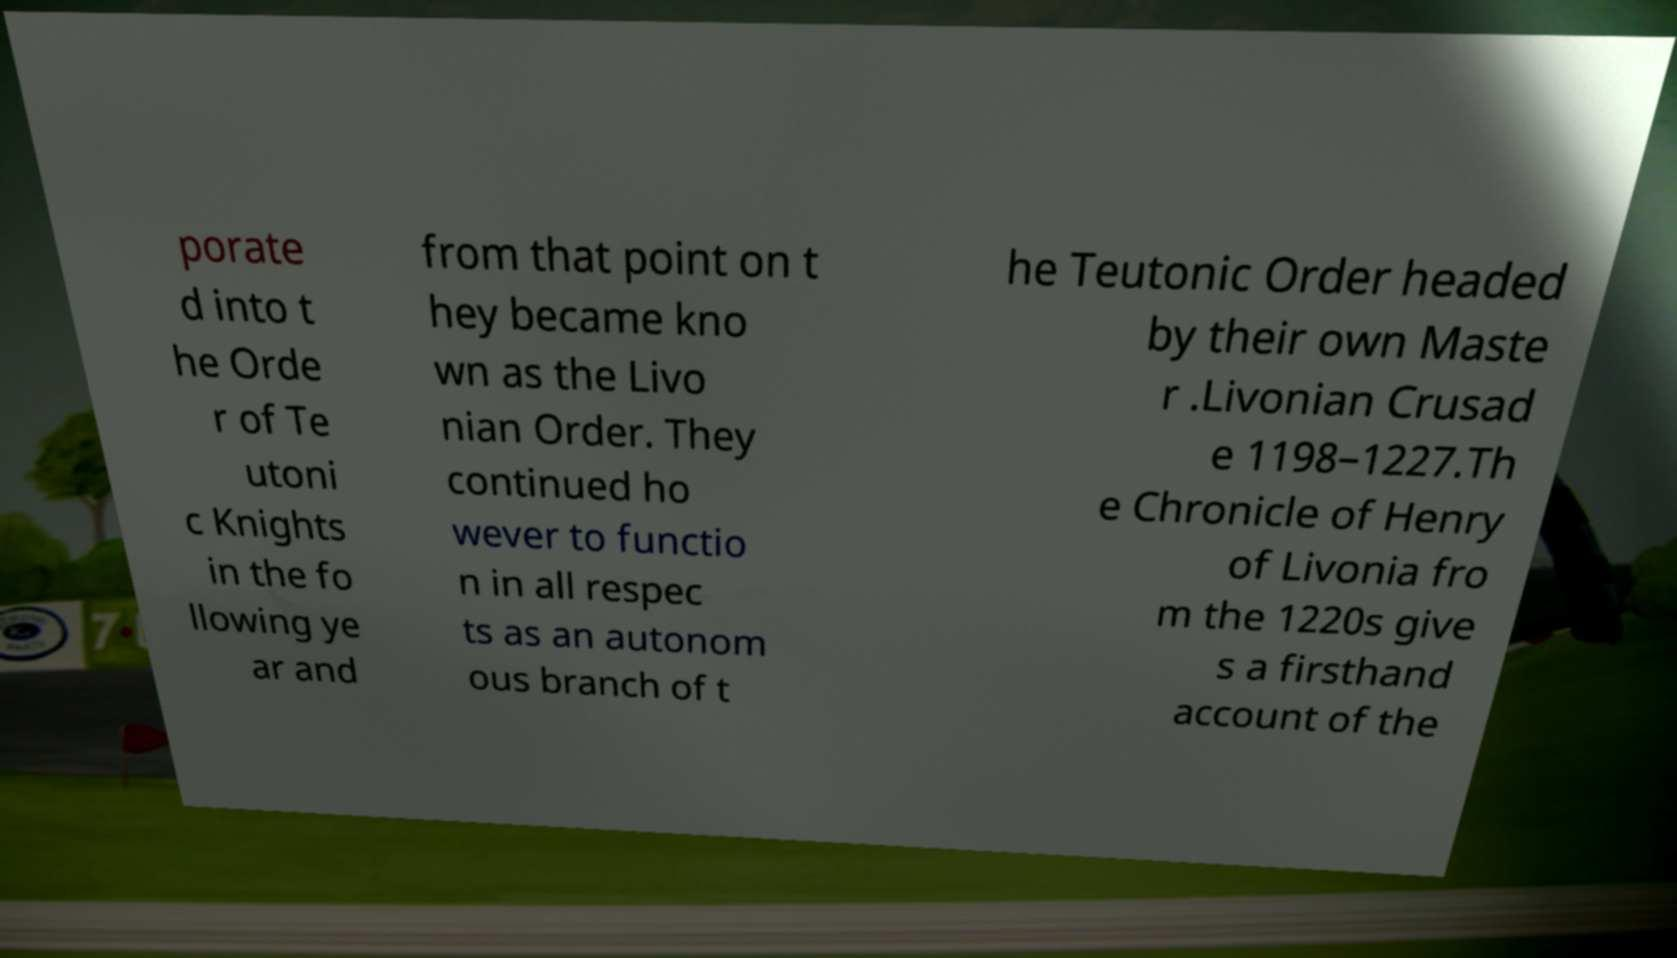Could you extract and type out the text from this image? porate d into t he Orde r of Te utoni c Knights in the fo llowing ye ar and from that point on t hey became kno wn as the Livo nian Order. They continued ho wever to functio n in all respec ts as an autonom ous branch of t he Teutonic Order headed by their own Maste r .Livonian Crusad e 1198–1227.Th e Chronicle of Henry of Livonia fro m the 1220s give s a firsthand account of the 